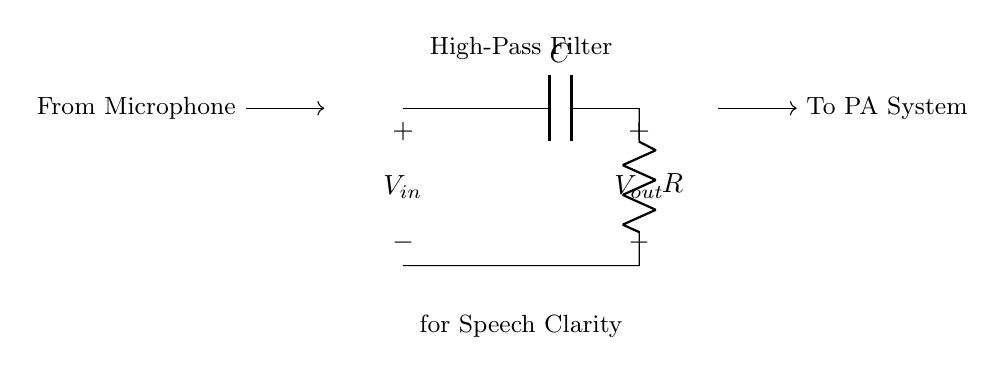What components are present in this circuit? The circuit includes a capacitor (C) and a resistor (R), which are the basic components of a high-pass filter.
Answer: capacitor and resistor What is the role of the capacitor in this high-pass filter? The capacitor allows high-frequency signals to pass through while blocking low-frequency signals, thereby improving speech clarity.
Answer: allow high frequencies What is the input voltage labeled in the circuit? The input voltage is denoted as V in with an open connection at the input side of the circuit, representing the signal coming from the microphone.
Answer: V in How is the output voltage taken in this circuit? The output voltage is taken across the resistor, which is where the filtered signal is output to the public address system.
Answer: V out What type of filter is this circuit implementing? This circuit implements a high-pass filter, which is specifically designed to pass higher frequencies while attenuating lower frequencies.
Answer: high-pass filter What does the arrow pointing to "To PA System" indicate? The arrow indicates the direction of signal flow from the output of the filter to the public address system, showing how the filtered audio is utilized.
Answer: direction of signal flow How would the clarity of speech be affected by this filter? By eliminating unwanted low-frequency noise, this filter enhances speech clarity, making it easier for the audience to understand during the fundraising event.
Answer: improves speech clarity 